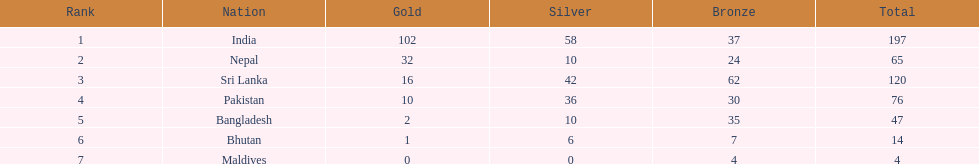How does the medal count differ between the nation with the highest and the nation with the lowest number of medals? 193. 